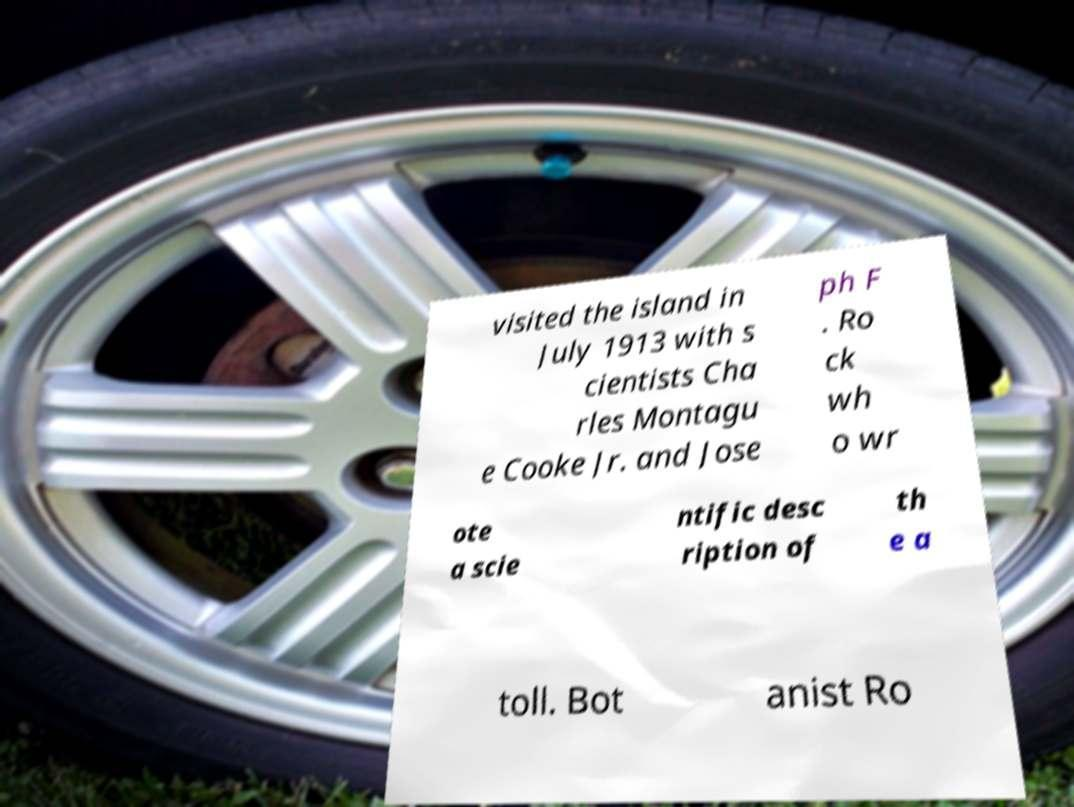Can you read and provide the text displayed in the image?This photo seems to have some interesting text. Can you extract and type it out for me? visited the island in July 1913 with s cientists Cha rles Montagu e Cooke Jr. and Jose ph F . Ro ck wh o wr ote a scie ntific desc ription of th e a toll. Bot anist Ro 